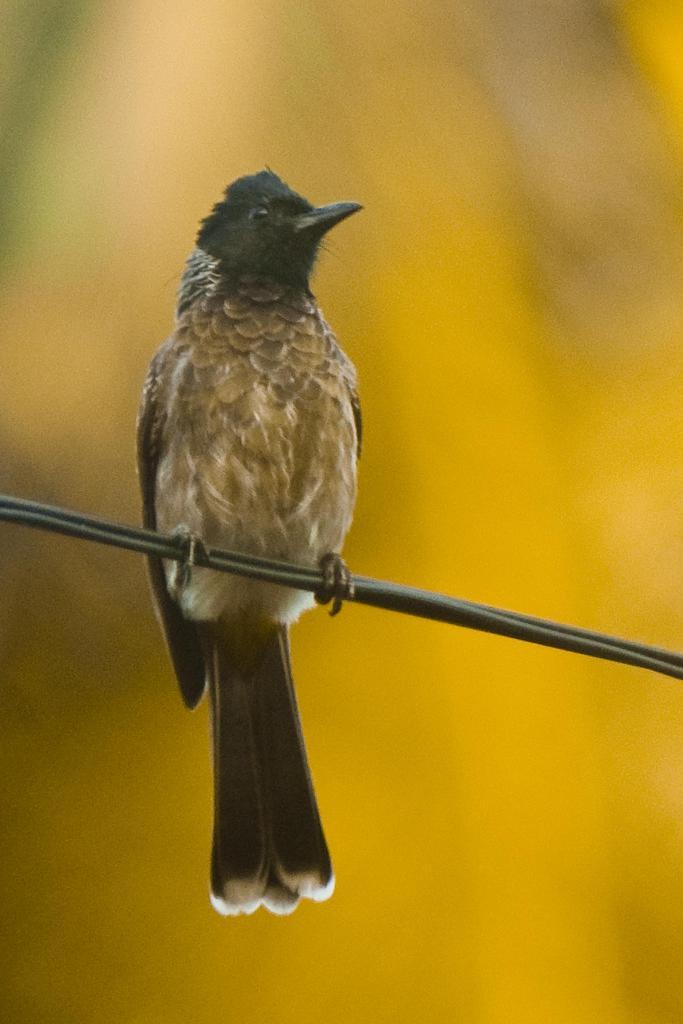What type of animal is in the image? There is a bird in the image. Where is the bird located? The bird is on a wire. Can you describe the background of the image? The background of the image is blurred. What type of shade does the stranger use to cover the brake in the image? There is no shade, stranger, or brake present in the image; it features a bird on a wire with a blurred background. 